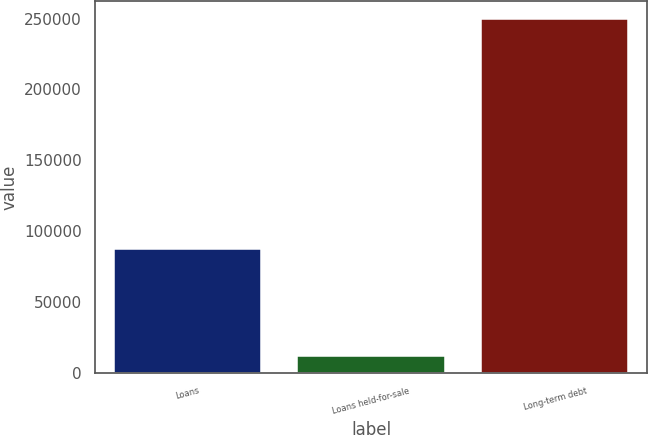<chart> <loc_0><loc_0><loc_500><loc_500><bar_chart><fcel>Loans<fcel>Loans held-for-sale<fcel>Long-term debt<nl><fcel>87174<fcel>12236<fcel>249692<nl></chart> 